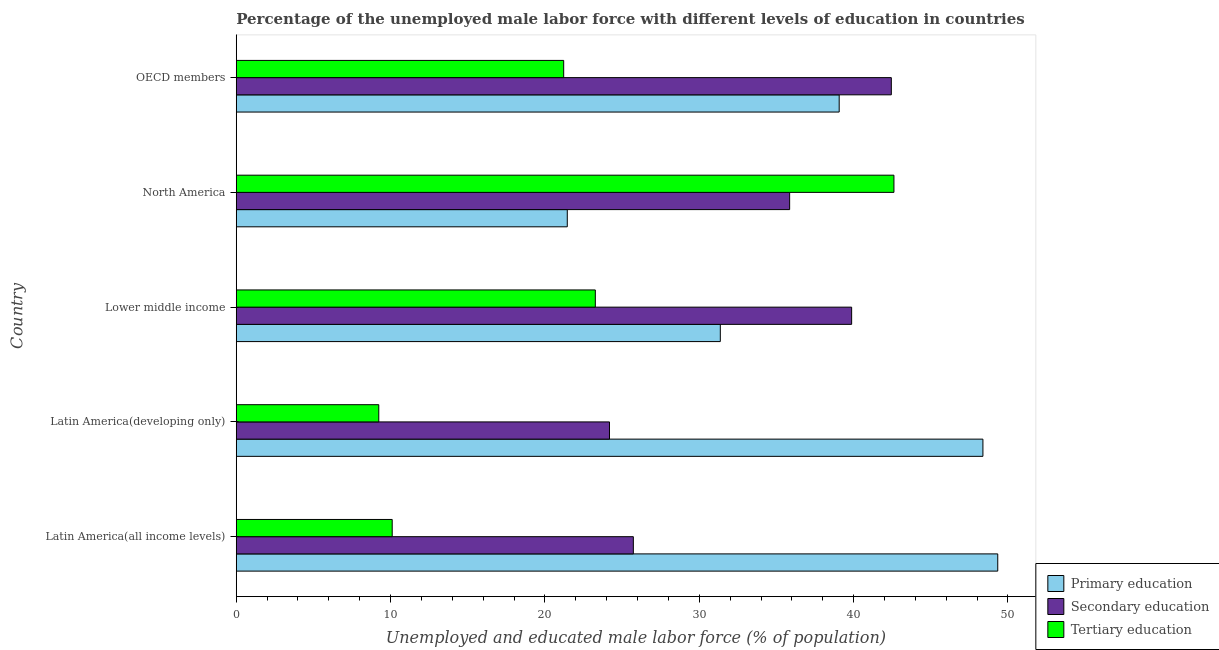How many groups of bars are there?
Offer a terse response. 5. Are the number of bars on each tick of the Y-axis equal?
Keep it short and to the point. Yes. How many bars are there on the 2nd tick from the bottom?
Your answer should be compact. 3. What is the label of the 3rd group of bars from the top?
Offer a terse response. Lower middle income. In how many cases, is the number of bars for a given country not equal to the number of legend labels?
Your answer should be very brief. 0. What is the percentage of male labor force who received primary education in Lower middle income?
Provide a short and direct response. 31.36. Across all countries, what is the maximum percentage of male labor force who received secondary education?
Your response must be concise. 42.44. Across all countries, what is the minimum percentage of male labor force who received tertiary education?
Offer a very short reply. 9.23. In which country was the percentage of male labor force who received primary education maximum?
Keep it short and to the point. Latin America(all income levels). In which country was the percentage of male labor force who received secondary education minimum?
Your answer should be very brief. Latin America(developing only). What is the total percentage of male labor force who received secondary education in the graph?
Offer a terse response. 168.08. What is the difference between the percentage of male labor force who received secondary education in Latin America(developing only) and the percentage of male labor force who received tertiary education in North America?
Offer a very short reply. -18.43. What is the average percentage of male labor force who received primary education per country?
Give a very brief answer. 37.92. What is the difference between the percentage of male labor force who received tertiary education and percentage of male labor force who received secondary education in Lower middle income?
Ensure brevity in your answer.  -16.61. What is the ratio of the percentage of male labor force who received primary education in Lower middle income to that in OECD members?
Offer a terse response. 0.8. Is the difference between the percentage of male labor force who received secondary education in Latin America(developing only) and North America greater than the difference between the percentage of male labor force who received tertiary education in Latin America(developing only) and North America?
Provide a succinct answer. Yes. What is the difference between the highest and the second highest percentage of male labor force who received tertiary education?
Make the answer very short. 19.35. What is the difference between the highest and the lowest percentage of male labor force who received secondary education?
Make the answer very short. 18.26. What does the 3rd bar from the top in Latin America(all income levels) represents?
Your response must be concise. Primary education. What does the 2nd bar from the bottom in Latin America(developing only) represents?
Your answer should be very brief. Secondary education. Does the graph contain any zero values?
Offer a terse response. No. Does the graph contain grids?
Provide a succinct answer. No. Where does the legend appear in the graph?
Make the answer very short. Bottom right. How many legend labels are there?
Your answer should be very brief. 3. How are the legend labels stacked?
Offer a terse response. Vertical. What is the title of the graph?
Ensure brevity in your answer.  Percentage of the unemployed male labor force with different levels of education in countries. Does "Ages 15-20" appear as one of the legend labels in the graph?
Keep it short and to the point. No. What is the label or title of the X-axis?
Ensure brevity in your answer.  Unemployed and educated male labor force (% of population). What is the Unemployed and educated male labor force (% of population) of Primary education in Latin America(all income levels)?
Give a very brief answer. 49.34. What is the Unemployed and educated male labor force (% of population) of Secondary education in Latin America(all income levels)?
Offer a terse response. 25.73. What is the Unemployed and educated male labor force (% of population) in Tertiary education in Latin America(all income levels)?
Provide a succinct answer. 10.1. What is the Unemployed and educated male labor force (% of population) in Primary education in Latin America(developing only)?
Provide a short and direct response. 48.38. What is the Unemployed and educated male labor force (% of population) of Secondary education in Latin America(developing only)?
Give a very brief answer. 24.18. What is the Unemployed and educated male labor force (% of population) in Tertiary education in Latin America(developing only)?
Make the answer very short. 9.23. What is the Unemployed and educated male labor force (% of population) of Primary education in Lower middle income?
Keep it short and to the point. 31.36. What is the Unemployed and educated male labor force (% of population) of Secondary education in Lower middle income?
Make the answer very short. 39.87. What is the Unemployed and educated male labor force (% of population) of Tertiary education in Lower middle income?
Ensure brevity in your answer.  23.26. What is the Unemployed and educated male labor force (% of population) in Primary education in North America?
Offer a very short reply. 21.45. What is the Unemployed and educated male labor force (% of population) in Secondary education in North America?
Offer a very short reply. 35.85. What is the Unemployed and educated male labor force (% of population) in Tertiary education in North America?
Keep it short and to the point. 42.61. What is the Unemployed and educated male labor force (% of population) in Primary education in OECD members?
Ensure brevity in your answer.  39.06. What is the Unemployed and educated male labor force (% of population) in Secondary education in OECD members?
Your answer should be compact. 42.44. What is the Unemployed and educated male labor force (% of population) of Tertiary education in OECD members?
Keep it short and to the point. 21.21. Across all countries, what is the maximum Unemployed and educated male labor force (% of population) in Primary education?
Offer a very short reply. 49.34. Across all countries, what is the maximum Unemployed and educated male labor force (% of population) in Secondary education?
Provide a short and direct response. 42.44. Across all countries, what is the maximum Unemployed and educated male labor force (% of population) of Tertiary education?
Ensure brevity in your answer.  42.61. Across all countries, what is the minimum Unemployed and educated male labor force (% of population) in Primary education?
Provide a succinct answer. 21.45. Across all countries, what is the minimum Unemployed and educated male labor force (% of population) in Secondary education?
Your answer should be compact. 24.18. Across all countries, what is the minimum Unemployed and educated male labor force (% of population) of Tertiary education?
Ensure brevity in your answer.  9.23. What is the total Unemployed and educated male labor force (% of population) in Primary education in the graph?
Ensure brevity in your answer.  189.59. What is the total Unemployed and educated male labor force (% of population) of Secondary education in the graph?
Offer a very short reply. 168.08. What is the total Unemployed and educated male labor force (% of population) in Tertiary education in the graph?
Ensure brevity in your answer.  106.43. What is the difference between the Unemployed and educated male labor force (% of population) of Primary education in Latin America(all income levels) and that in Latin America(developing only)?
Provide a succinct answer. 0.96. What is the difference between the Unemployed and educated male labor force (% of population) of Secondary education in Latin America(all income levels) and that in Latin America(developing only)?
Your answer should be compact. 1.55. What is the difference between the Unemployed and educated male labor force (% of population) of Tertiary education in Latin America(all income levels) and that in Latin America(developing only)?
Offer a very short reply. 0.87. What is the difference between the Unemployed and educated male labor force (% of population) of Primary education in Latin America(all income levels) and that in Lower middle income?
Provide a succinct answer. 17.98. What is the difference between the Unemployed and educated male labor force (% of population) of Secondary education in Latin America(all income levels) and that in Lower middle income?
Provide a short and direct response. -14.14. What is the difference between the Unemployed and educated male labor force (% of population) in Tertiary education in Latin America(all income levels) and that in Lower middle income?
Offer a terse response. -13.16. What is the difference between the Unemployed and educated male labor force (% of population) in Primary education in Latin America(all income levels) and that in North America?
Provide a succinct answer. 27.89. What is the difference between the Unemployed and educated male labor force (% of population) in Secondary education in Latin America(all income levels) and that in North America?
Provide a succinct answer. -10.13. What is the difference between the Unemployed and educated male labor force (% of population) in Tertiary education in Latin America(all income levels) and that in North America?
Make the answer very short. -32.51. What is the difference between the Unemployed and educated male labor force (% of population) in Primary education in Latin America(all income levels) and that in OECD members?
Your response must be concise. 10.27. What is the difference between the Unemployed and educated male labor force (% of population) of Secondary education in Latin America(all income levels) and that in OECD members?
Provide a succinct answer. -16.71. What is the difference between the Unemployed and educated male labor force (% of population) in Tertiary education in Latin America(all income levels) and that in OECD members?
Your answer should be very brief. -11.11. What is the difference between the Unemployed and educated male labor force (% of population) of Primary education in Latin America(developing only) and that in Lower middle income?
Your answer should be very brief. 17.02. What is the difference between the Unemployed and educated male labor force (% of population) of Secondary education in Latin America(developing only) and that in Lower middle income?
Offer a terse response. -15.69. What is the difference between the Unemployed and educated male labor force (% of population) in Tertiary education in Latin America(developing only) and that in Lower middle income?
Ensure brevity in your answer.  -14.03. What is the difference between the Unemployed and educated male labor force (% of population) of Primary education in Latin America(developing only) and that in North America?
Keep it short and to the point. 26.93. What is the difference between the Unemployed and educated male labor force (% of population) of Secondary education in Latin America(developing only) and that in North America?
Your answer should be compact. -11.67. What is the difference between the Unemployed and educated male labor force (% of population) in Tertiary education in Latin America(developing only) and that in North America?
Provide a short and direct response. -33.38. What is the difference between the Unemployed and educated male labor force (% of population) of Primary education in Latin America(developing only) and that in OECD members?
Your answer should be very brief. 9.31. What is the difference between the Unemployed and educated male labor force (% of population) of Secondary education in Latin America(developing only) and that in OECD members?
Your response must be concise. -18.26. What is the difference between the Unemployed and educated male labor force (% of population) in Tertiary education in Latin America(developing only) and that in OECD members?
Give a very brief answer. -11.98. What is the difference between the Unemployed and educated male labor force (% of population) of Primary education in Lower middle income and that in North America?
Ensure brevity in your answer.  9.91. What is the difference between the Unemployed and educated male labor force (% of population) of Secondary education in Lower middle income and that in North America?
Give a very brief answer. 4.02. What is the difference between the Unemployed and educated male labor force (% of population) in Tertiary education in Lower middle income and that in North America?
Make the answer very short. -19.35. What is the difference between the Unemployed and educated male labor force (% of population) in Primary education in Lower middle income and that in OECD members?
Give a very brief answer. -7.7. What is the difference between the Unemployed and educated male labor force (% of population) of Secondary education in Lower middle income and that in OECD members?
Your response must be concise. -2.57. What is the difference between the Unemployed and educated male labor force (% of population) in Tertiary education in Lower middle income and that in OECD members?
Offer a terse response. 2.05. What is the difference between the Unemployed and educated male labor force (% of population) of Primary education in North America and that in OECD members?
Make the answer very short. -17.62. What is the difference between the Unemployed and educated male labor force (% of population) of Secondary education in North America and that in OECD members?
Offer a terse response. -6.59. What is the difference between the Unemployed and educated male labor force (% of population) of Tertiary education in North America and that in OECD members?
Offer a terse response. 21.4. What is the difference between the Unemployed and educated male labor force (% of population) of Primary education in Latin America(all income levels) and the Unemployed and educated male labor force (% of population) of Secondary education in Latin America(developing only)?
Keep it short and to the point. 25.16. What is the difference between the Unemployed and educated male labor force (% of population) of Primary education in Latin America(all income levels) and the Unemployed and educated male labor force (% of population) of Tertiary education in Latin America(developing only)?
Your answer should be very brief. 40.1. What is the difference between the Unemployed and educated male labor force (% of population) of Secondary education in Latin America(all income levels) and the Unemployed and educated male labor force (% of population) of Tertiary education in Latin America(developing only)?
Give a very brief answer. 16.49. What is the difference between the Unemployed and educated male labor force (% of population) in Primary education in Latin America(all income levels) and the Unemployed and educated male labor force (% of population) in Secondary education in Lower middle income?
Ensure brevity in your answer.  9.47. What is the difference between the Unemployed and educated male labor force (% of population) of Primary education in Latin America(all income levels) and the Unemployed and educated male labor force (% of population) of Tertiary education in Lower middle income?
Provide a short and direct response. 26.07. What is the difference between the Unemployed and educated male labor force (% of population) of Secondary education in Latin America(all income levels) and the Unemployed and educated male labor force (% of population) of Tertiary education in Lower middle income?
Your answer should be very brief. 2.46. What is the difference between the Unemployed and educated male labor force (% of population) in Primary education in Latin America(all income levels) and the Unemployed and educated male labor force (% of population) in Secondary education in North America?
Your answer should be compact. 13.48. What is the difference between the Unemployed and educated male labor force (% of population) of Primary education in Latin America(all income levels) and the Unemployed and educated male labor force (% of population) of Tertiary education in North America?
Provide a succinct answer. 6.73. What is the difference between the Unemployed and educated male labor force (% of population) of Secondary education in Latin America(all income levels) and the Unemployed and educated male labor force (% of population) of Tertiary education in North America?
Give a very brief answer. -16.88. What is the difference between the Unemployed and educated male labor force (% of population) of Primary education in Latin America(all income levels) and the Unemployed and educated male labor force (% of population) of Secondary education in OECD members?
Keep it short and to the point. 6.89. What is the difference between the Unemployed and educated male labor force (% of population) of Primary education in Latin America(all income levels) and the Unemployed and educated male labor force (% of population) of Tertiary education in OECD members?
Provide a succinct answer. 28.12. What is the difference between the Unemployed and educated male labor force (% of population) of Secondary education in Latin America(all income levels) and the Unemployed and educated male labor force (% of population) of Tertiary education in OECD members?
Make the answer very short. 4.51. What is the difference between the Unemployed and educated male labor force (% of population) in Primary education in Latin America(developing only) and the Unemployed and educated male labor force (% of population) in Secondary education in Lower middle income?
Offer a terse response. 8.51. What is the difference between the Unemployed and educated male labor force (% of population) in Primary education in Latin America(developing only) and the Unemployed and educated male labor force (% of population) in Tertiary education in Lower middle income?
Keep it short and to the point. 25.11. What is the difference between the Unemployed and educated male labor force (% of population) of Secondary education in Latin America(developing only) and the Unemployed and educated male labor force (% of population) of Tertiary education in Lower middle income?
Provide a short and direct response. 0.92. What is the difference between the Unemployed and educated male labor force (% of population) of Primary education in Latin America(developing only) and the Unemployed and educated male labor force (% of population) of Secondary education in North America?
Make the answer very short. 12.52. What is the difference between the Unemployed and educated male labor force (% of population) of Primary education in Latin America(developing only) and the Unemployed and educated male labor force (% of population) of Tertiary education in North America?
Make the answer very short. 5.77. What is the difference between the Unemployed and educated male labor force (% of population) in Secondary education in Latin America(developing only) and the Unemployed and educated male labor force (% of population) in Tertiary education in North America?
Make the answer very short. -18.43. What is the difference between the Unemployed and educated male labor force (% of population) of Primary education in Latin America(developing only) and the Unemployed and educated male labor force (% of population) of Secondary education in OECD members?
Make the answer very short. 5.93. What is the difference between the Unemployed and educated male labor force (% of population) in Primary education in Latin America(developing only) and the Unemployed and educated male labor force (% of population) in Tertiary education in OECD members?
Keep it short and to the point. 27.16. What is the difference between the Unemployed and educated male labor force (% of population) in Secondary education in Latin America(developing only) and the Unemployed and educated male labor force (% of population) in Tertiary education in OECD members?
Give a very brief answer. 2.97. What is the difference between the Unemployed and educated male labor force (% of population) in Primary education in Lower middle income and the Unemployed and educated male labor force (% of population) in Secondary education in North America?
Your answer should be very brief. -4.49. What is the difference between the Unemployed and educated male labor force (% of population) in Primary education in Lower middle income and the Unemployed and educated male labor force (% of population) in Tertiary education in North America?
Keep it short and to the point. -11.25. What is the difference between the Unemployed and educated male labor force (% of population) of Secondary education in Lower middle income and the Unemployed and educated male labor force (% of population) of Tertiary education in North America?
Your answer should be very brief. -2.74. What is the difference between the Unemployed and educated male labor force (% of population) of Primary education in Lower middle income and the Unemployed and educated male labor force (% of population) of Secondary education in OECD members?
Provide a short and direct response. -11.08. What is the difference between the Unemployed and educated male labor force (% of population) in Primary education in Lower middle income and the Unemployed and educated male labor force (% of population) in Tertiary education in OECD members?
Your answer should be very brief. 10.15. What is the difference between the Unemployed and educated male labor force (% of population) in Secondary education in Lower middle income and the Unemployed and educated male labor force (% of population) in Tertiary education in OECD members?
Give a very brief answer. 18.66. What is the difference between the Unemployed and educated male labor force (% of population) of Primary education in North America and the Unemployed and educated male labor force (% of population) of Secondary education in OECD members?
Offer a very short reply. -20.99. What is the difference between the Unemployed and educated male labor force (% of population) of Primary education in North America and the Unemployed and educated male labor force (% of population) of Tertiary education in OECD members?
Make the answer very short. 0.23. What is the difference between the Unemployed and educated male labor force (% of population) in Secondary education in North America and the Unemployed and educated male labor force (% of population) in Tertiary education in OECD members?
Your response must be concise. 14.64. What is the average Unemployed and educated male labor force (% of population) in Primary education per country?
Keep it short and to the point. 37.92. What is the average Unemployed and educated male labor force (% of population) of Secondary education per country?
Keep it short and to the point. 33.62. What is the average Unemployed and educated male labor force (% of population) in Tertiary education per country?
Keep it short and to the point. 21.29. What is the difference between the Unemployed and educated male labor force (% of population) of Primary education and Unemployed and educated male labor force (% of population) of Secondary education in Latin America(all income levels)?
Your answer should be very brief. 23.61. What is the difference between the Unemployed and educated male labor force (% of population) of Primary education and Unemployed and educated male labor force (% of population) of Tertiary education in Latin America(all income levels)?
Give a very brief answer. 39.23. What is the difference between the Unemployed and educated male labor force (% of population) of Secondary education and Unemployed and educated male labor force (% of population) of Tertiary education in Latin America(all income levels)?
Your answer should be very brief. 15.62. What is the difference between the Unemployed and educated male labor force (% of population) of Primary education and Unemployed and educated male labor force (% of population) of Secondary education in Latin America(developing only)?
Keep it short and to the point. 24.2. What is the difference between the Unemployed and educated male labor force (% of population) in Primary education and Unemployed and educated male labor force (% of population) in Tertiary education in Latin America(developing only)?
Provide a succinct answer. 39.14. What is the difference between the Unemployed and educated male labor force (% of population) of Secondary education and Unemployed and educated male labor force (% of population) of Tertiary education in Latin America(developing only)?
Provide a succinct answer. 14.95. What is the difference between the Unemployed and educated male labor force (% of population) in Primary education and Unemployed and educated male labor force (% of population) in Secondary education in Lower middle income?
Ensure brevity in your answer.  -8.51. What is the difference between the Unemployed and educated male labor force (% of population) of Primary education and Unemployed and educated male labor force (% of population) of Tertiary education in Lower middle income?
Your response must be concise. 8.1. What is the difference between the Unemployed and educated male labor force (% of population) of Secondary education and Unemployed and educated male labor force (% of population) of Tertiary education in Lower middle income?
Ensure brevity in your answer.  16.61. What is the difference between the Unemployed and educated male labor force (% of population) in Primary education and Unemployed and educated male labor force (% of population) in Secondary education in North America?
Your answer should be very brief. -14.41. What is the difference between the Unemployed and educated male labor force (% of population) of Primary education and Unemployed and educated male labor force (% of population) of Tertiary education in North America?
Provide a short and direct response. -21.16. What is the difference between the Unemployed and educated male labor force (% of population) in Secondary education and Unemployed and educated male labor force (% of population) in Tertiary education in North America?
Offer a terse response. -6.76. What is the difference between the Unemployed and educated male labor force (% of population) of Primary education and Unemployed and educated male labor force (% of population) of Secondary education in OECD members?
Your answer should be compact. -3.38. What is the difference between the Unemployed and educated male labor force (% of population) of Primary education and Unemployed and educated male labor force (% of population) of Tertiary education in OECD members?
Make the answer very short. 17.85. What is the difference between the Unemployed and educated male labor force (% of population) in Secondary education and Unemployed and educated male labor force (% of population) in Tertiary education in OECD members?
Keep it short and to the point. 21.23. What is the ratio of the Unemployed and educated male labor force (% of population) in Primary education in Latin America(all income levels) to that in Latin America(developing only)?
Offer a terse response. 1.02. What is the ratio of the Unemployed and educated male labor force (% of population) in Secondary education in Latin America(all income levels) to that in Latin America(developing only)?
Provide a succinct answer. 1.06. What is the ratio of the Unemployed and educated male labor force (% of population) in Tertiary education in Latin America(all income levels) to that in Latin America(developing only)?
Your answer should be very brief. 1.09. What is the ratio of the Unemployed and educated male labor force (% of population) of Primary education in Latin America(all income levels) to that in Lower middle income?
Offer a terse response. 1.57. What is the ratio of the Unemployed and educated male labor force (% of population) of Secondary education in Latin America(all income levels) to that in Lower middle income?
Ensure brevity in your answer.  0.65. What is the ratio of the Unemployed and educated male labor force (% of population) of Tertiary education in Latin America(all income levels) to that in Lower middle income?
Ensure brevity in your answer.  0.43. What is the ratio of the Unemployed and educated male labor force (% of population) of Primary education in Latin America(all income levels) to that in North America?
Keep it short and to the point. 2.3. What is the ratio of the Unemployed and educated male labor force (% of population) of Secondary education in Latin America(all income levels) to that in North America?
Make the answer very short. 0.72. What is the ratio of the Unemployed and educated male labor force (% of population) of Tertiary education in Latin America(all income levels) to that in North America?
Provide a short and direct response. 0.24. What is the ratio of the Unemployed and educated male labor force (% of population) of Primary education in Latin America(all income levels) to that in OECD members?
Keep it short and to the point. 1.26. What is the ratio of the Unemployed and educated male labor force (% of population) in Secondary education in Latin America(all income levels) to that in OECD members?
Ensure brevity in your answer.  0.61. What is the ratio of the Unemployed and educated male labor force (% of population) in Tertiary education in Latin America(all income levels) to that in OECD members?
Provide a succinct answer. 0.48. What is the ratio of the Unemployed and educated male labor force (% of population) in Primary education in Latin America(developing only) to that in Lower middle income?
Your answer should be compact. 1.54. What is the ratio of the Unemployed and educated male labor force (% of population) in Secondary education in Latin America(developing only) to that in Lower middle income?
Ensure brevity in your answer.  0.61. What is the ratio of the Unemployed and educated male labor force (% of population) in Tertiary education in Latin America(developing only) to that in Lower middle income?
Your answer should be very brief. 0.4. What is the ratio of the Unemployed and educated male labor force (% of population) in Primary education in Latin America(developing only) to that in North America?
Keep it short and to the point. 2.26. What is the ratio of the Unemployed and educated male labor force (% of population) of Secondary education in Latin America(developing only) to that in North America?
Provide a succinct answer. 0.67. What is the ratio of the Unemployed and educated male labor force (% of population) in Tertiary education in Latin America(developing only) to that in North America?
Your response must be concise. 0.22. What is the ratio of the Unemployed and educated male labor force (% of population) of Primary education in Latin America(developing only) to that in OECD members?
Your answer should be compact. 1.24. What is the ratio of the Unemployed and educated male labor force (% of population) in Secondary education in Latin America(developing only) to that in OECD members?
Your response must be concise. 0.57. What is the ratio of the Unemployed and educated male labor force (% of population) of Tertiary education in Latin America(developing only) to that in OECD members?
Offer a very short reply. 0.44. What is the ratio of the Unemployed and educated male labor force (% of population) in Primary education in Lower middle income to that in North America?
Provide a short and direct response. 1.46. What is the ratio of the Unemployed and educated male labor force (% of population) of Secondary education in Lower middle income to that in North America?
Offer a terse response. 1.11. What is the ratio of the Unemployed and educated male labor force (% of population) of Tertiary education in Lower middle income to that in North America?
Your answer should be compact. 0.55. What is the ratio of the Unemployed and educated male labor force (% of population) in Primary education in Lower middle income to that in OECD members?
Offer a very short reply. 0.8. What is the ratio of the Unemployed and educated male labor force (% of population) in Secondary education in Lower middle income to that in OECD members?
Offer a very short reply. 0.94. What is the ratio of the Unemployed and educated male labor force (% of population) of Tertiary education in Lower middle income to that in OECD members?
Provide a short and direct response. 1.1. What is the ratio of the Unemployed and educated male labor force (% of population) in Primary education in North America to that in OECD members?
Your response must be concise. 0.55. What is the ratio of the Unemployed and educated male labor force (% of population) of Secondary education in North America to that in OECD members?
Keep it short and to the point. 0.84. What is the ratio of the Unemployed and educated male labor force (% of population) of Tertiary education in North America to that in OECD members?
Make the answer very short. 2.01. What is the difference between the highest and the second highest Unemployed and educated male labor force (% of population) of Primary education?
Provide a short and direct response. 0.96. What is the difference between the highest and the second highest Unemployed and educated male labor force (% of population) of Secondary education?
Offer a very short reply. 2.57. What is the difference between the highest and the second highest Unemployed and educated male labor force (% of population) of Tertiary education?
Make the answer very short. 19.35. What is the difference between the highest and the lowest Unemployed and educated male labor force (% of population) of Primary education?
Provide a short and direct response. 27.89. What is the difference between the highest and the lowest Unemployed and educated male labor force (% of population) of Secondary education?
Offer a terse response. 18.26. What is the difference between the highest and the lowest Unemployed and educated male labor force (% of population) in Tertiary education?
Your answer should be very brief. 33.38. 